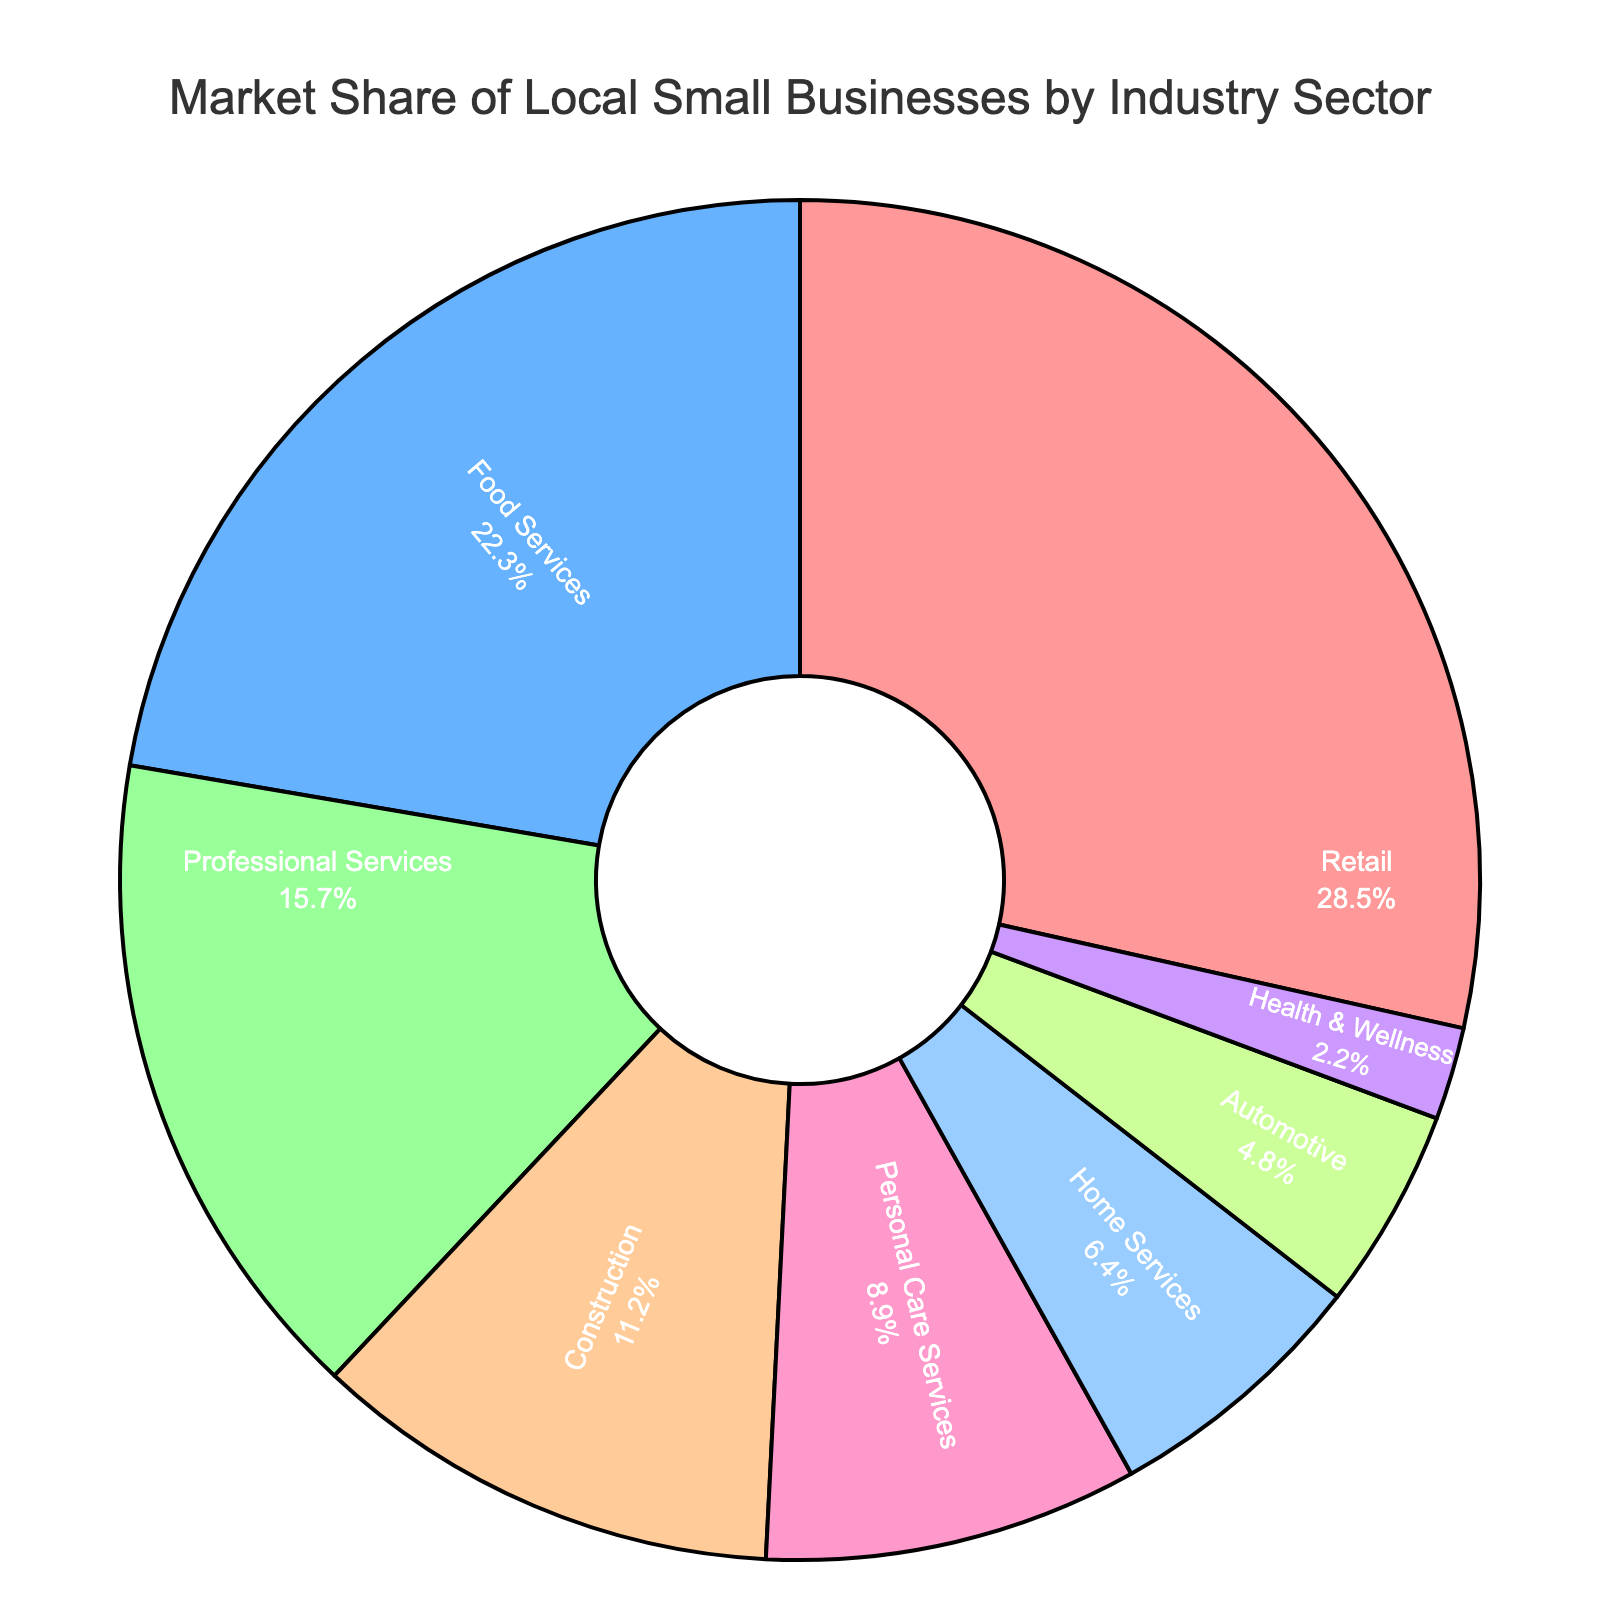What is the industry with the largest market share? The largest market share can be identified by looking at the percentage values on the pie chart. Retail is marked with the highest percentage of 28.5%.
Answer: Retail What is the combined market share of Food Services and Construction? To find the combined market share, sum the percentages for Food Services (22.3%) and Construction (11.2%). So, 22.3% + 11.2% = 33.5%.
Answer: 33.5% Which industries have a market share below 5%? Identify all the industries with a market share below 5% by looking at the percentages on the pie chart. Health & Wellness (2.2%) and Automotive (4.8%).
Answer: Health & Wellness, Automotive How much greater is the market share of Retail compared to Health & Wellness? Subtract the market share of Health & Wellness (2.2%) from Retail (28.5%) to find the difference: 28.5% - 2.2% = 26.3%.
Answer: 26.3% If you combine the Personal Care Services and Home Services sectors, how does their total market share compare to that of the Professional Services sector? Sum the market shares of Personal Care Services (8.9%) and Home Services (6.4%), then compare to Professional Services (15.7%). 8.9% + 6.4% = 15.3%, which is slightly less than Professional Services (15.7%).
Answer: Slightly less What is the sum of the market shares for industries with more than 10% market share? Add the percentages for industries with more than 10% market share: Retail (28.5%), Food Services (22.3%), and Professional Services (15.7%). 28.5% + 22.3% + 15.7% = 66.5%.
Answer: 66.5% Which industry has the smallest market share and what is its percentage? Identify the smallest percentage in the pie chart. Health & Wellness has the smallest market share at 2.2%.
Answer: Health & Wellness, 2.2% How many sectors have market shares above 20%? Count the number of sectors with market share percentages above 20% by inspecting the chart. Retail (28.5%) and Food Services (22.3%) are the only ones above 20%.
Answer: 2 What is the average market share of all industries listed in the pie chart? To calculate the average, sum all market shares and divide by the number of industries. Sum: 28.5 + 22.3 + 15.7 + 11.2 + 8.9 + 6.4 + 4.8 + 2.2 = 100%. There are 8 industries, so average = 100% / 8 = 12.5%.
Answer: 12.5% Which segment color represents the Construction industry? The Construction industry is marked with a specified color. The pie chart's sequence shows that Construction is represented by the fourth color, which is orange.
Answer: Orange 